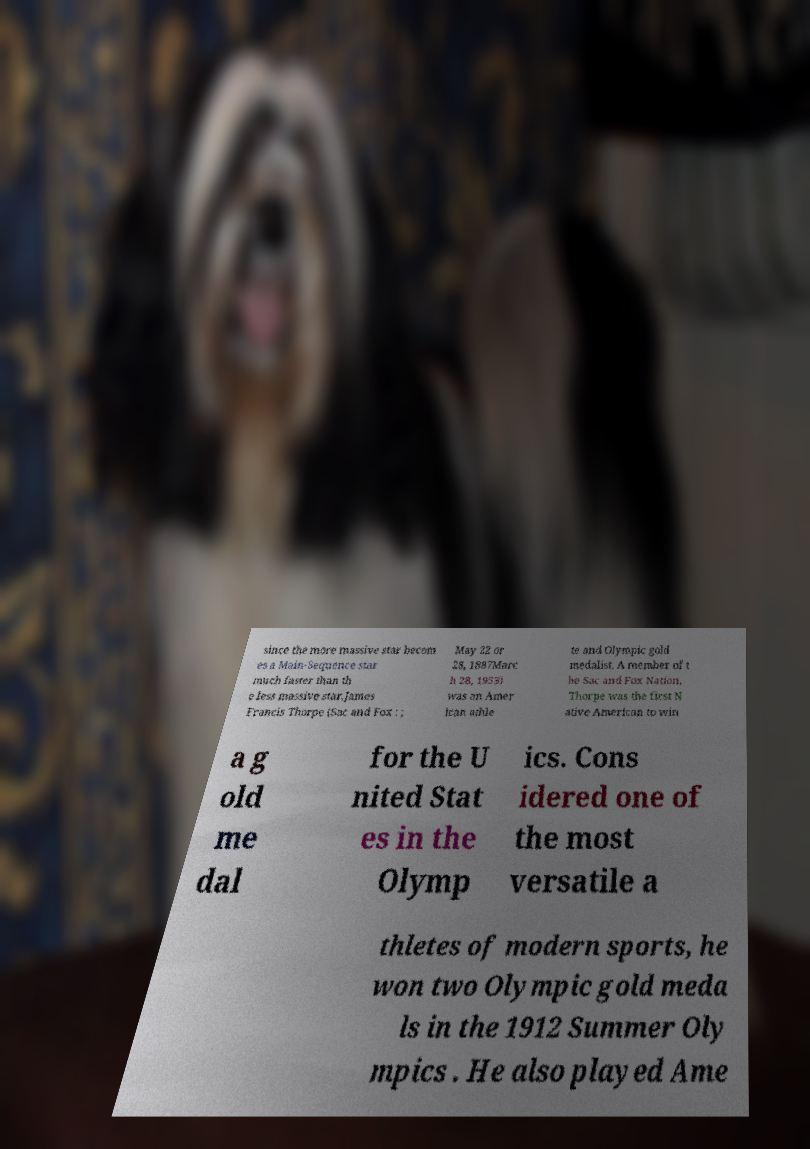Can you read and provide the text displayed in the image?This photo seems to have some interesting text. Can you extract and type it out for me? since the more massive star becom es a Main-Sequence star much faster than th e less massive star.James Francis Thorpe (Sac and Fox : ; May 22 or 28, 1887Marc h 28, 1953) was an Amer ican athle te and Olympic gold medalist. A member of t he Sac and Fox Nation, Thorpe was the first N ative American to win a g old me dal for the U nited Stat es in the Olymp ics. Cons idered one of the most versatile a thletes of modern sports, he won two Olympic gold meda ls in the 1912 Summer Oly mpics . He also played Ame 